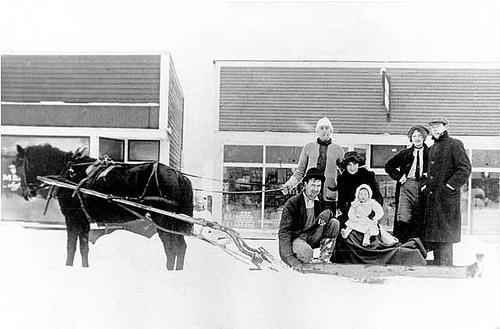Question: when is the picture taken?
Choices:
A. Just before dinner.
B. Evening.
C. During the day.
D. 9:15am.
Answer with the letter. Answer: C Question: who is in the picture?
Choices:
A. A tennis player.
B. A family.
C. 3 children.
D. A cat.
Answer with the letter. Answer: B Question: what color is the horse?
Choices:
A. Brown.
B. Gray.
C. White.
D. Black.
Answer with the letter. Answer: D 